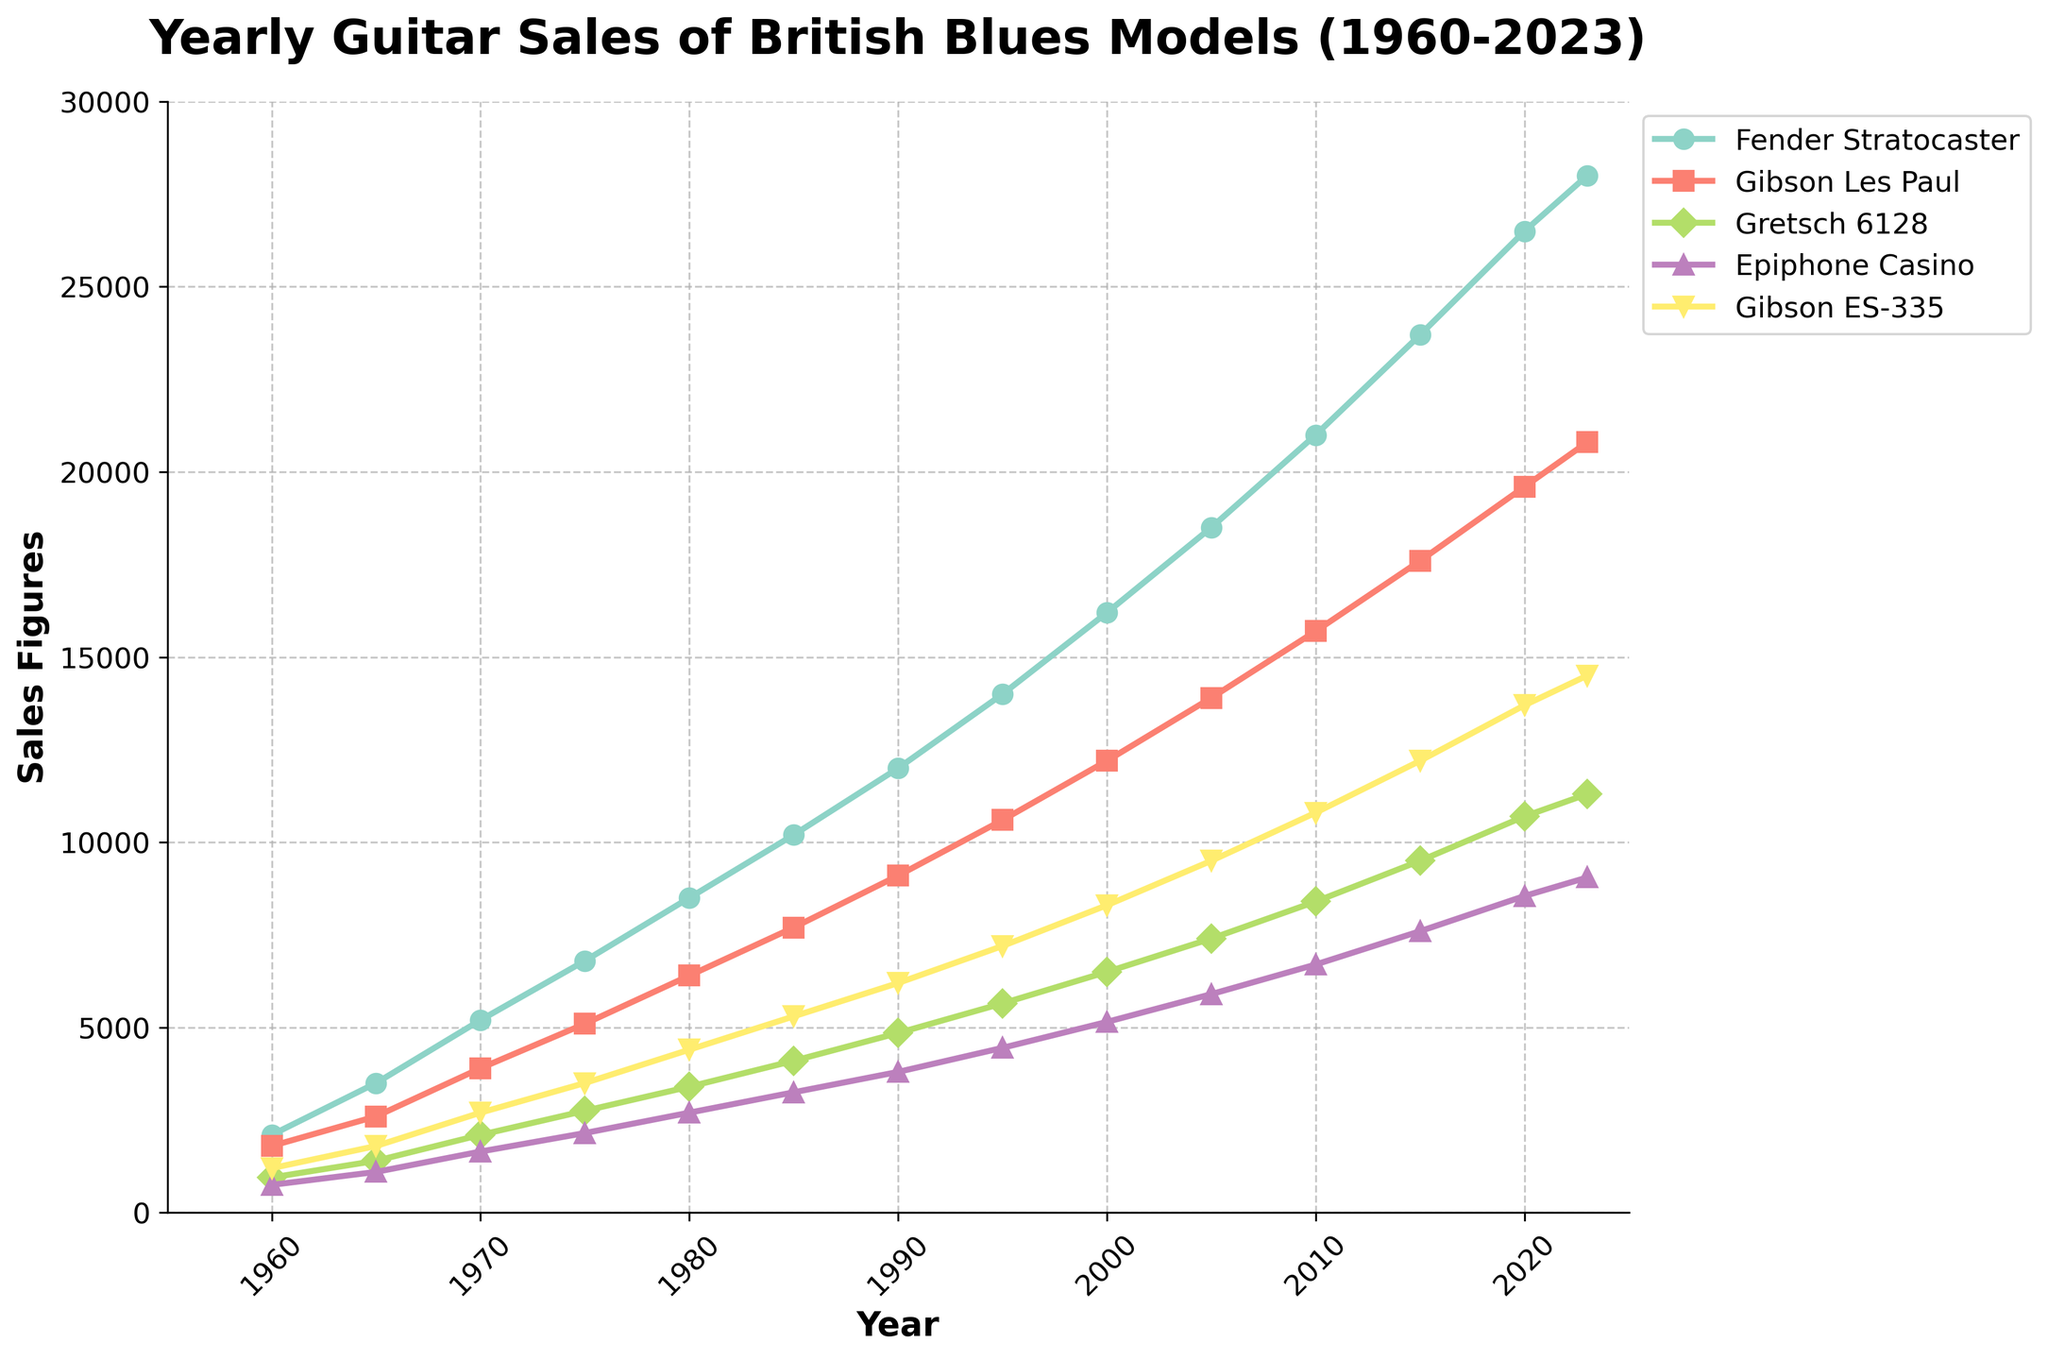What's the highest sales figure for the Fender Stratocaster and in which year did it occur? The highest sales figure for the Fender Stratocaster can be seen at the end of the plotted line for the Fender Stratocaster model in the year 2023, where it reaches 28,000 units.
Answer: 28,000 in 2023 Which guitar model had the lowest sales figure in 1965 and what was that figure? In 1965, the lowest sales figure among the guitar models was for the Epiphone Casino, which can be seen at the lowest point on the line corresponding to the Epiphone Casino model. This figure was 1,100 units.
Answer: Epiphone Casino, 1,100 Between 1970 and 1980, which model showed the largest increase in sales, and by how much? To find this, we compare the differences in sales figures between 1970 and 1980 for each model. The largest increase is seen with the Fender Stratocaster: 8500 (1980) - 5200 (1970) = 3300 units.
Answer: Fender Stratocaster, 3,300 From 1985 to 1990, which guitar model had the smallest increase in sales figures? By calculating the increase in sales for each model between 1985 and 1990, we can see the smallest increase was for the Gretsch 6128: 4850 (1990) - 4100 (1985) = 750 units.
Answer: Gretsch 6128, 750 units In which year did the Gibson Les Paul first surpass 10,000 sales figures, and by how much was it surpassed? Observing the sales figures for the Gibson Les Paul, we see it first surpasses 10,000 in 1995 where the sales are 10,600: 10,600 - 10,000 = 600 units above 10,000.
Answer: 1995, by 600 units Compare the sales figures for the Epiphone Casino and the Gibson ES-335 in 1980. Which model had higher sales and what is the difference? In 1980, the sales figures for the Epiphone Casino were 2,700 units, while the sales for the Gibson ES-335 were 4,400 units. The Gibson ES-335 had higher sales by 4,400 - 2,700 = 1,700 units.
Answer: Gibson ES-335 by 1,700 units What was the average annual sales figure of the Gretsch 6128 between 1960 to 2023? To calculate the average, add the sales figures for the Gretsch 6128 from 1960 to 2023 and divide by 14 (total number of recorded years). Summing the values: 950 + 1400 + 2100 + 2750 + 3400 + 4100 + 4850 + 5650 + 6500 + 7400 + 8400 + 9500 + 10700 + 11300 = 79,550. Then: 79,550 / 14 ≈ 5,682 units.
Answer: Approximately 5,682 units How did the sales of the Fender Stratocaster in 2020 compare to those in 1970? Calculate the percentage increase. Sales in 2020 were 26,500 units and in 1970 were 5,200 units. Calculate the percentage increase: [(26,500 - 5,200) / 5,200] * 100 ≈ 409.62%.
Answer: Approximately 409.62% Between 2000 and 2010, which guitar model had the most consistent growth in sales figures? Define consistency as the smallest standard deviation in annual sales growth over the decade. To answer this, calculate the standard deviation of yearly increases for each model from 2000 to 2010. The model with the smallest standard deviation in yearly increases shows the most consistent growth. However, visual inspection of the graph for such an analysis shows the Gibson ES-335 possibly demonstrates a fairly steady upward trend without pronounced fluctuations. More accurate answer requires detailed calculation which isn't visible here.
Answer: Gibson ES-335 (visual inspection) Which model had the highest sales figure in 2023, and how does it compare with the lowest sales figure in 2023? In 2023, the highest sales figure is for the Fender Stratocaster with 28,000 units, while the lowest is for the Epiphone Casino with 9,050 units. The difference is 28,000 - 9,050 = 18,950 units.
Answer: Fender Stratocaster, difference of 18,950 units 